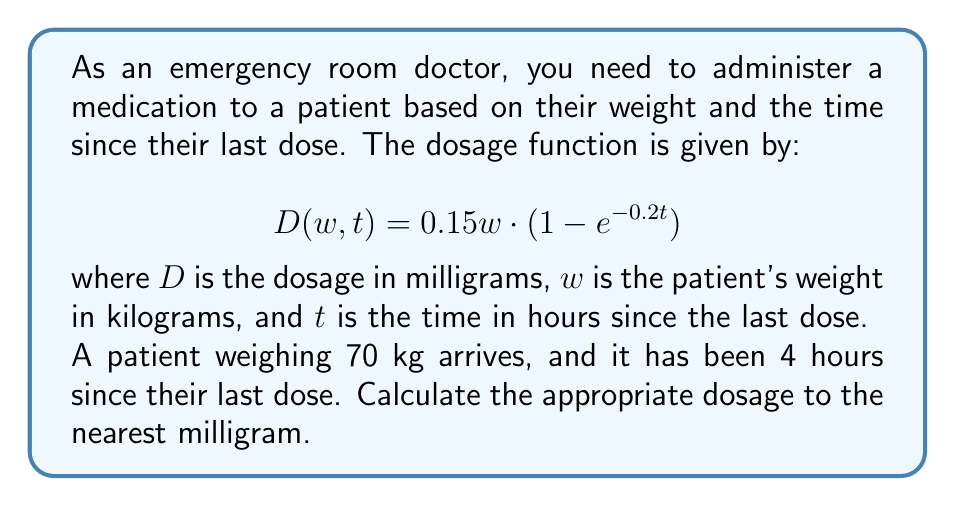Solve this math problem. To solve this problem, we need to follow these steps:

1. Identify the given values:
   $w = 70$ kg (patient's weight)
   $t = 4$ hours (time since last dose)

2. Substitute these values into the dosage function:
   $$ D(70, 4) = 0.15 \cdot 70 \cdot (1 - e^{-0.2 \cdot 4}) $$

3. Simplify the expression inside the parentheses:
   $$ D(70, 4) = 0.15 \cdot 70 \cdot (1 - e^{-0.8}) $$

4. Calculate $e^{-0.8}$ using a calculator:
   $e^{-0.8} \approx 0.4493$

5. Subtract this value from 1:
   $1 - 0.4493 = 0.5507$

6. Multiply the result by 0.15 and 70:
   $$ D(70, 4) = 0.15 \cdot 70 \cdot 0.5507 = 5.78235 $$

7. Round to the nearest milligram:
   $5.78235 \approx 6$ mg

Therefore, the appropriate dosage for this patient is 6 mg.
Answer: 6 mg 